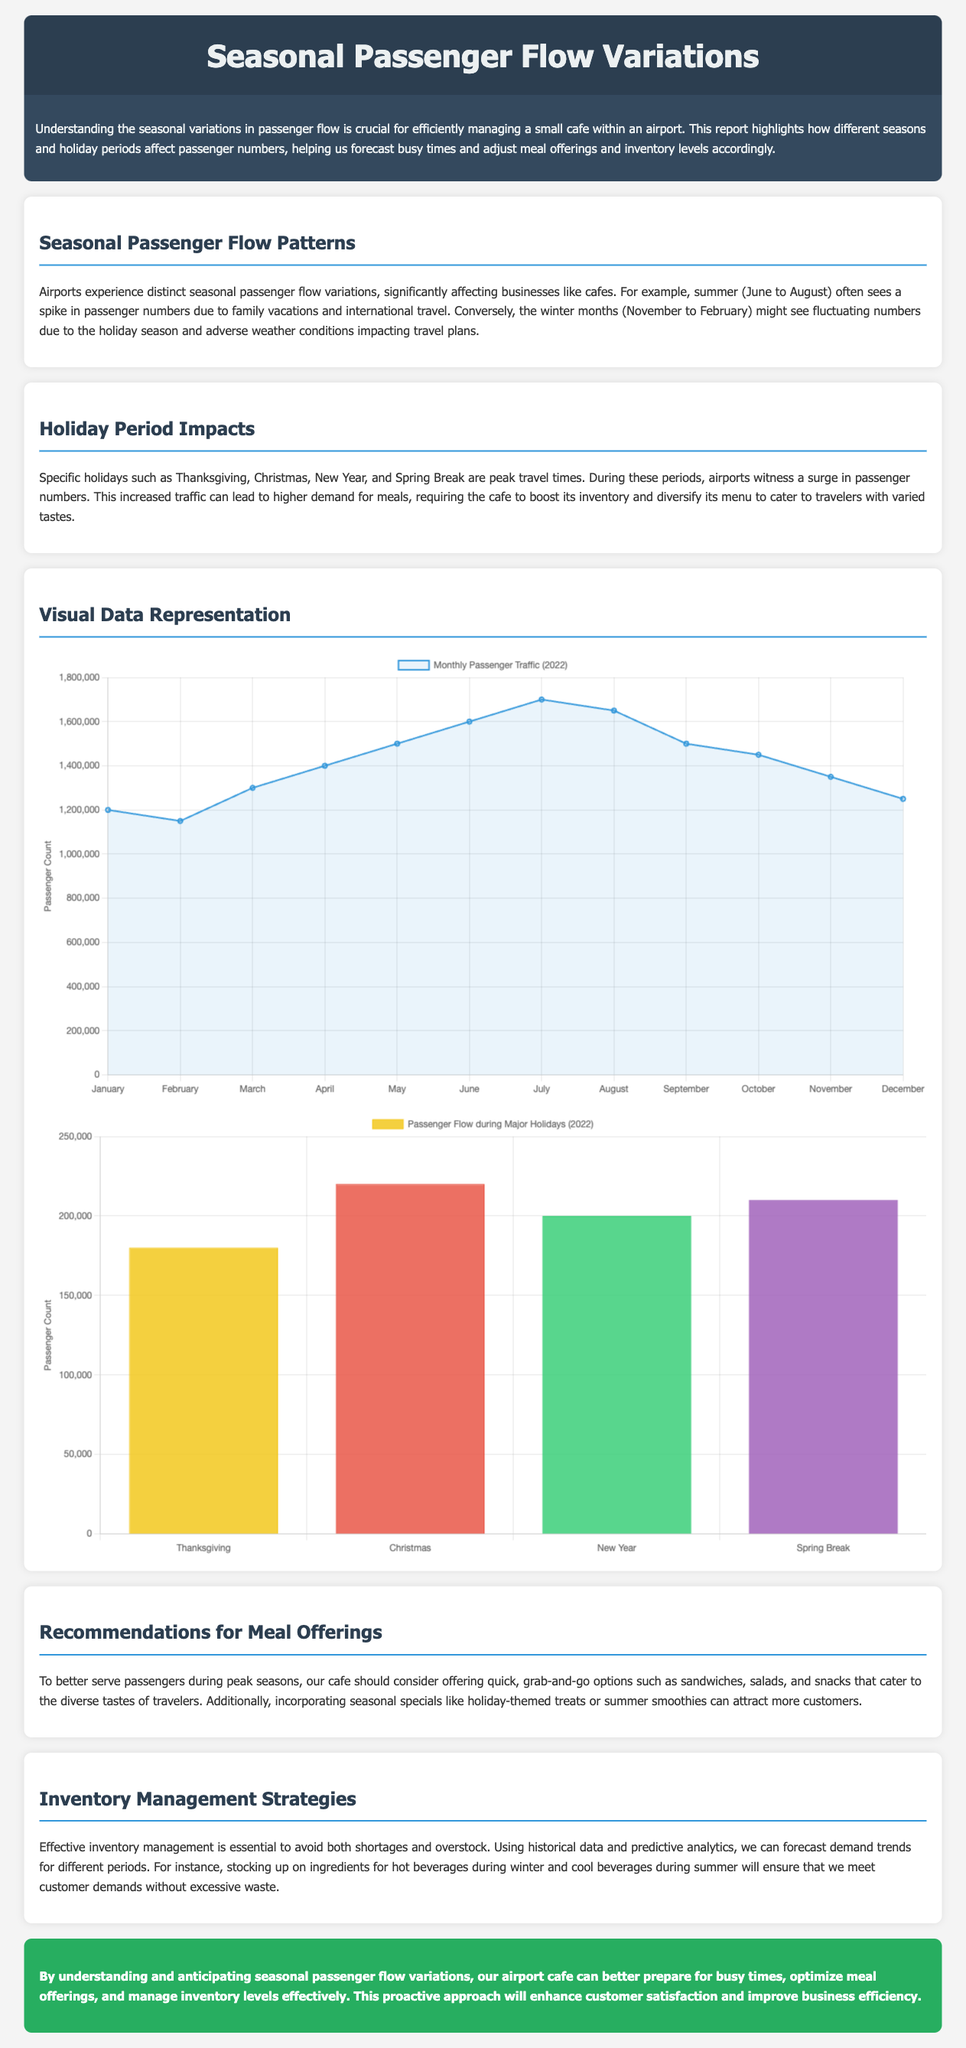What is the peak passenger count during Christmas? The peak passenger count during Christmas is stated in the holiday chart data section as 220000.
Answer: 220000 During which months does summer occur according to the report? The report specifies summer as occurring from June to August.
Answer: June to August What food offerings are recommended for peak seasons? The report suggests offering quick, grab-and-go options such as sandwiches, salads, and snacks.
Answer: Sandwiches, salads, and snacks How many passengers are projected in July? The monthly passenger traffic chart lists July's projected passengers as 1700000.
Answer: 1700000 What holiday period has the highest passenger flow according to the report? The holiday chart indicates that Christmas has the highest passenger flow.
Answer: Christmas What strategy is suggested for inventory management? The report suggests using historical data and predictive analytics for inventory management.
Answer: Predictive analytics What is the document type of this report? This document is a Traffic report focused on passenger flow variations.
Answer: Traffic report What is the average passenger count for the winter months (December to February)? The average passenger count is calculated from the monthly traffic data provided for December to February.
Answer: 1283333.33 What is the conclusion regarding seasonal passenger flow? The conclusion emphasizes that understanding seasonal variations will enhance customer satisfaction and business efficiency.
Answer: Enhance customer satisfaction and business efficiency 